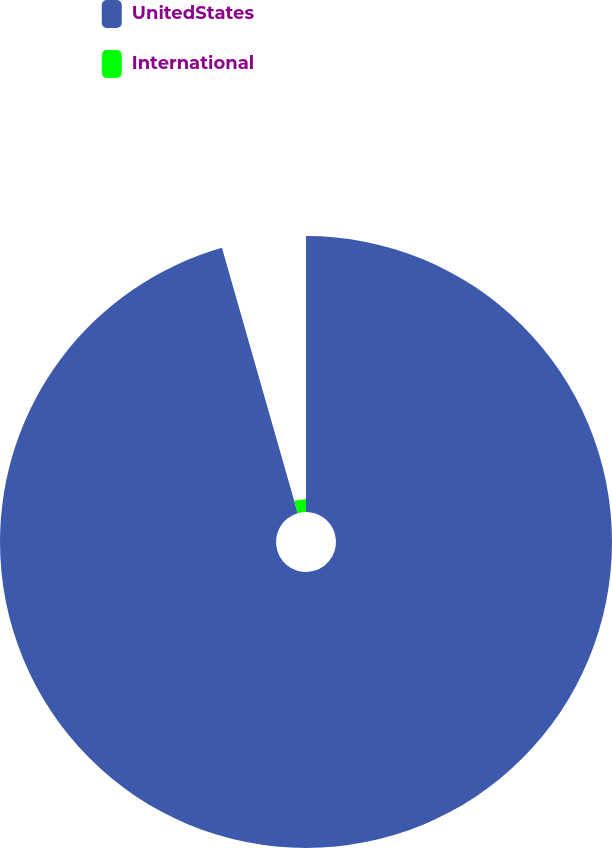Convert chart. <chart><loc_0><loc_0><loc_500><loc_500><pie_chart><fcel>UnitedStates<fcel>International<nl><fcel>95.57%<fcel>4.43%<nl></chart> 